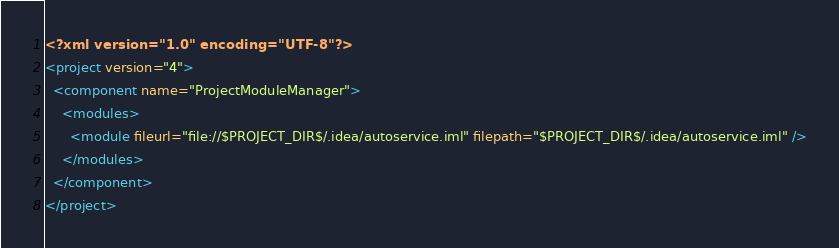Convert code to text. <code><loc_0><loc_0><loc_500><loc_500><_XML_><?xml version="1.0" encoding="UTF-8"?>
<project version="4">
  <component name="ProjectModuleManager">
    <modules>
      <module fileurl="file://$PROJECT_DIR$/.idea/autoservice.iml" filepath="$PROJECT_DIR$/.idea/autoservice.iml" />
    </modules>
  </component>
</project></code> 